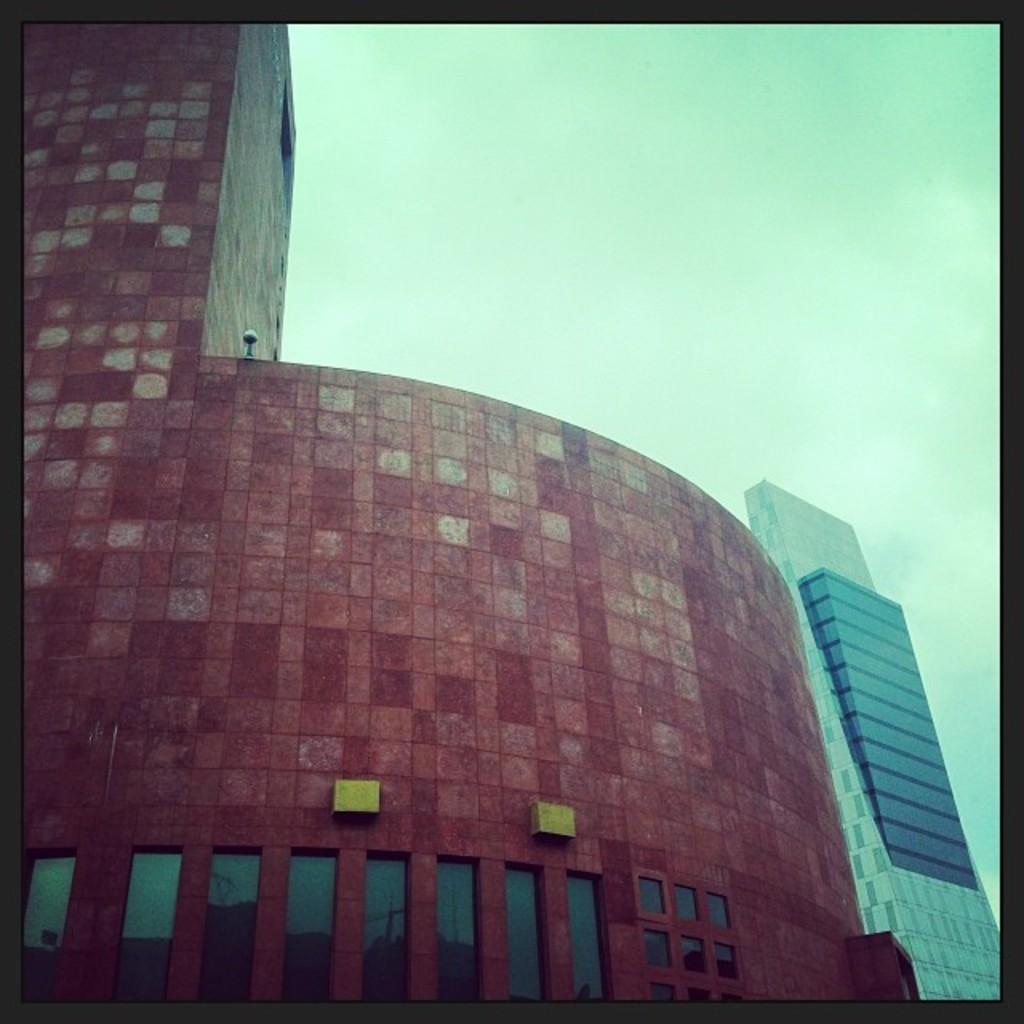Please provide a concise description of this image. In the center of the image we can see buildings are there. At the top of the image sky is there. 